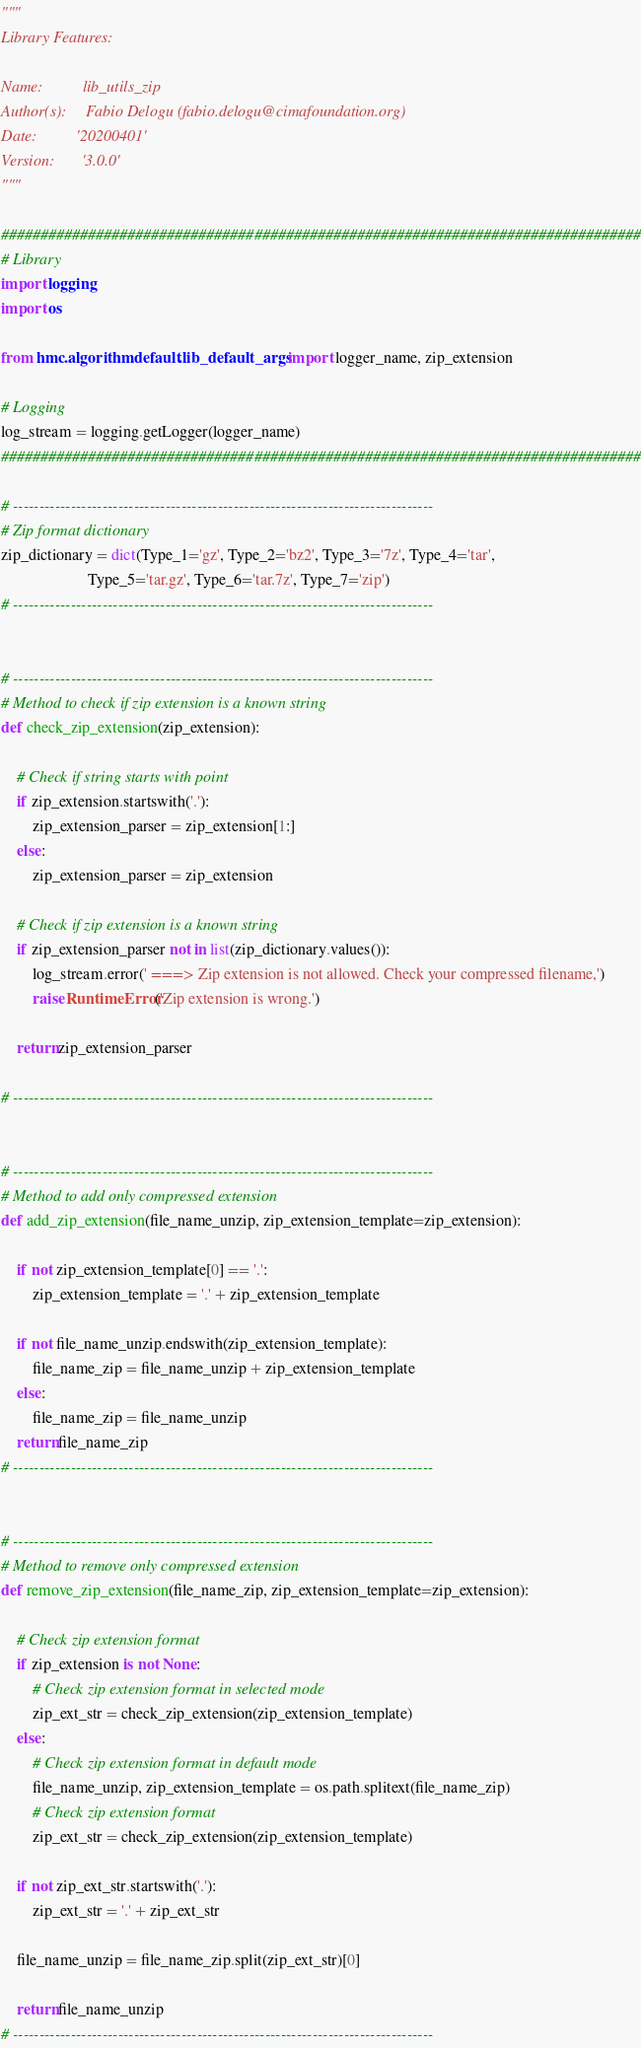<code> <loc_0><loc_0><loc_500><loc_500><_Python_>"""
Library Features:

Name:          lib_utils_zip
Author(s):     Fabio Delogu (fabio.delogu@cimafoundation.org)
Date:          '20200401'
Version:       '3.0.0'
"""

#################################################################################
# Library
import logging
import os

from hmc.algorithm.default.lib_default_args import logger_name, zip_extension

# Logging
log_stream = logging.getLogger(logger_name)
#################################################################################

# --------------------------------------------------------------------------------
# Zip format dictionary
zip_dictionary = dict(Type_1='gz', Type_2='bz2', Type_3='7z', Type_4='tar',
                      Type_5='tar.gz', Type_6='tar.7z', Type_7='zip')
# --------------------------------------------------------------------------------


# --------------------------------------------------------------------------------
# Method to check if zip extension is a known string
def check_zip_extension(zip_extension):

    # Check if string starts with point
    if zip_extension.startswith('.'):
        zip_extension_parser = zip_extension[1:]
    else:
        zip_extension_parser = zip_extension

    # Check if zip extension is a known string
    if zip_extension_parser not in list(zip_dictionary.values()):
        log_stream.error(' ===> Zip extension is not allowed. Check your compressed filename,')
        raise RuntimeError('Zip extension is wrong.')

    return zip_extension_parser

# --------------------------------------------------------------------------------


# --------------------------------------------------------------------------------
# Method to add only compressed extension
def add_zip_extension(file_name_unzip, zip_extension_template=zip_extension):

    if not zip_extension_template[0] == '.':
        zip_extension_template = '.' + zip_extension_template

    if not file_name_unzip.endswith(zip_extension_template):
        file_name_zip = file_name_unzip + zip_extension_template
    else:
        file_name_zip = file_name_unzip
    return file_name_zip
# --------------------------------------------------------------------------------


# --------------------------------------------------------------------------------
# Method to remove only compressed extension 
def remove_zip_extension(file_name_zip, zip_extension_template=zip_extension):

    # Check zip extension format
    if zip_extension is not None:
        # Check zip extension format in selected mode
        zip_ext_str = check_zip_extension(zip_extension_template)
    else:
        # Check zip extension format in default mode
        file_name_unzip, zip_extension_template = os.path.splitext(file_name_zip)
        # Check zip extension format
        zip_ext_str = check_zip_extension(zip_extension_template)

    if not zip_ext_str.startswith('.'):
        zip_ext_str = '.' + zip_ext_str

    file_name_unzip = file_name_zip.split(zip_ext_str)[0]

    return file_name_unzip
# --------------------------------------------------------------------------------
</code> 